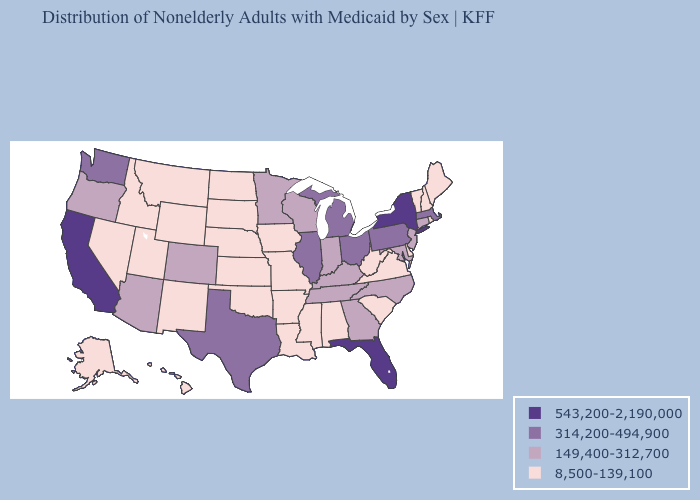Does Indiana have a lower value than Minnesota?
Give a very brief answer. No. What is the lowest value in the West?
Answer briefly. 8,500-139,100. Does Nebraska have the same value as Oklahoma?
Short answer required. Yes. Name the states that have a value in the range 149,400-312,700?
Give a very brief answer. Arizona, Colorado, Connecticut, Georgia, Indiana, Kentucky, Maryland, Minnesota, New Jersey, North Carolina, Oregon, Tennessee, Wisconsin. What is the value of Arkansas?
Write a very short answer. 8,500-139,100. Name the states that have a value in the range 8,500-139,100?
Concise answer only. Alabama, Alaska, Arkansas, Delaware, Hawaii, Idaho, Iowa, Kansas, Louisiana, Maine, Mississippi, Missouri, Montana, Nebraska, Nevada, New Hampshire, New Mexico, North Dakota, Oklahoma, Rhode Island, South Carolina, South Dakota, Utah, Vermont, Virginia, West Virginia, Wyoming. Which states have the lowest value in the USA?
Quick response, please. Alabama, Alaska, Arkansas, Delaware, Hawaii, Idaho, Iowa, Kansas, Louisiana, Maine, Mississippi, Missouri, Montana, Nebraska, Nevada, New Hampshire, New Mexico, North Dakota, Oklahoma, Rhode Island, South Carolina, South Dakota, Utah, Vermont, Virginia, West Virginia, Wyoming. What is the value of Connecticut?
Give a very brief answer. 149,400-312,700. What is the value of Missouri?
Give a very brief answer. 8,500-139,100. Which states hav the highest value in the South?
Write a very short answer. Florida. Among the states that border Massachusetts , does New York have the highest value?
Write a very short answer. Yes. Name the states that have a value in the range 149,400-312,700?
Short answer required. Arizona, Colorado, Connecticut, Georgia, Indiana, Kentucky, Maryland, Minnesota, New Jersey, North Carolina, Oregon, Tennessee, Wisconsin. What is the value of Colorado?
Give a very brief answer. 149,400-312,700. Does California have the lowest value in the West?
Be succinct. No. 